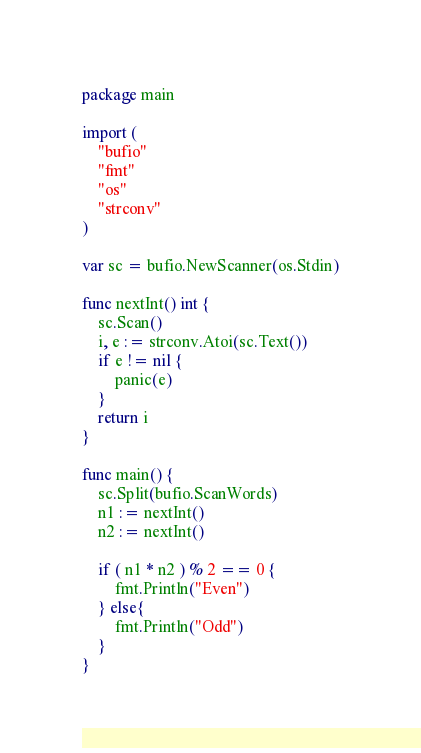Convert code to text. <code><loc_0><loc_0><loc_500><loc_500><_Go_>package main

import (
    "bufio"
    "fmt"
    "os"
    "strconv"
)

var sc = bufio.NewScanner(os.Stdin)

func nextInt() int {
    sc.Scan()
    i, e := strconv.Atoi(sc.Text())
    if e != nil {
        panic(e)
    }
    return i
}

func main() {
    sc.Split(bufio.ScanWords)
    n1 := nextInt()
    n2 := nextInt()

    if ( n1 * n2 ) % 2 == 0 {
        fmt.Println("Even")
    } else{
        fmt.Println("Odd")
    }
}
</code> 